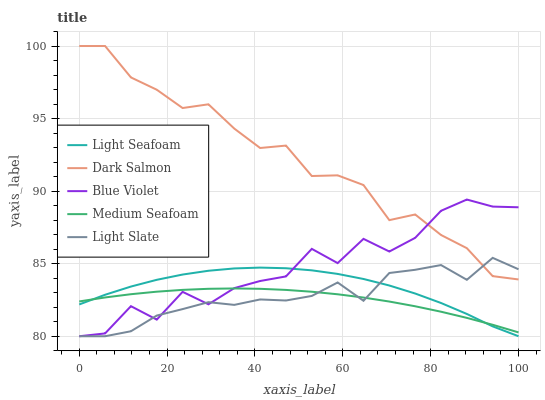Does Medium Seafoam have the minimum area under the curve?
Answer yes or no. Yes. Does Dark Salmon have the maximum area under the curve?
Answer yes or no. Yes. Does Light Seafoam have the minimum area under the curve?
Answer yes or no. No. Does Light Seafoam have the maximum area under the curve?
Answer yes or no. No. Is Medium Seafoam the smoothest?
Answer yes or no. Yes. Is Blue Violet the roughest?
Answer yes or no. Yes. Is Light Seafoam the smoothest?
Answer yes or no. No. Is Light Seafoam the roughest?
Answer yes or no. No. Does Light Slate have the lowest value?
Answer yes or no. Yes. Does Dark Salmon have the lowest value?
Answer yes or no. No. Does Dark Salmon have the highest value?
Answer yes or no. Yes. Does Light Seafoam have the highest value?
Answer yes or no. No. Is Medium Seafoam less than Dark Salmon?
Answer yes or no. Yes. Is Dark Salmon greater than Medium Seafoam?
Answer yes or no. Yes. Does Medium Seafoam intersect Light Slate?
Answer yes or no. Yes. Is Medium Seafoam less than Light Slate?
Answer yes or no. No. Is Medium Seafoam greater than Light Slate?
Answer yes or no. No. Does Medium Seafoam intersect Dark Salmon?
Answer yes or no. No. 